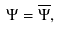Convert formula to latex. <formula><loc_0><loc_0><loc_500><loc_500>\Psi = \overline { \Psi } ,</formula> 